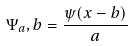<formula> <loc_0><loc_0><loc_500><loc_500>\Psi _ { a } , b = \frac { \psi ( x - b ) } { a }</formula> 